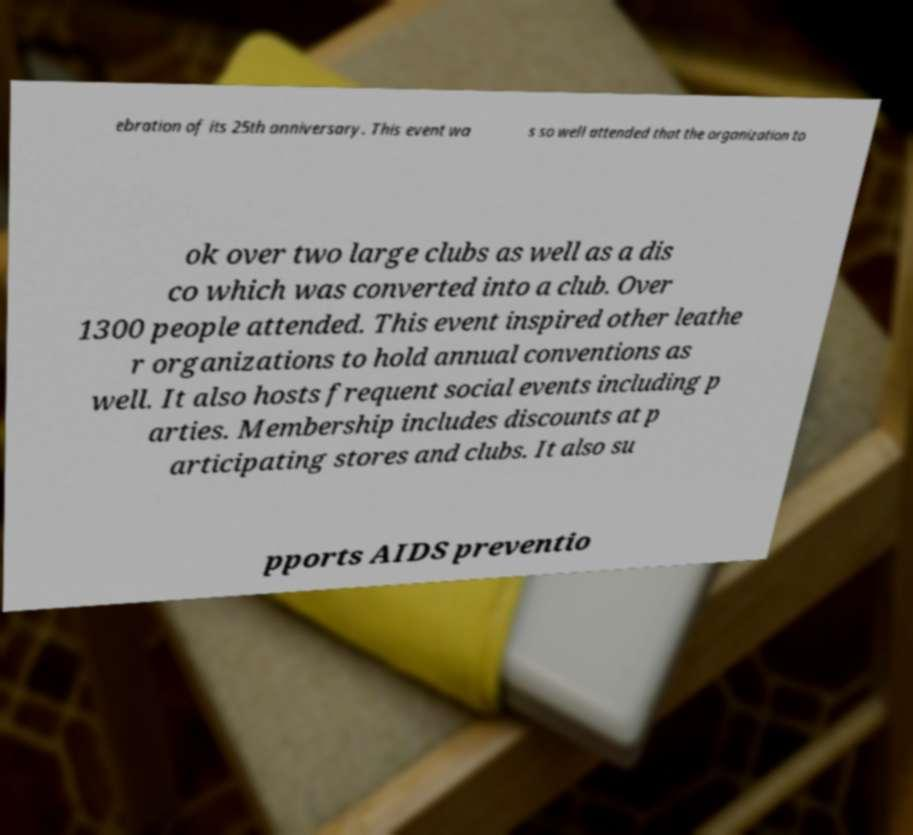Can you accurately transcribe the text from the provided image for me? ebration of its 25th anniversary. This event wa s so well attended that the organization to ok over two large clubs as well as a dis co which was converted into a club. Over 1300 people attended. This event inspired other leathe r organizations to hold annual conventions as well. It also hosts frequent social events including p arties. Membership includes discounts at p articipating stores and clubs. It also su pports AIDS preventio 